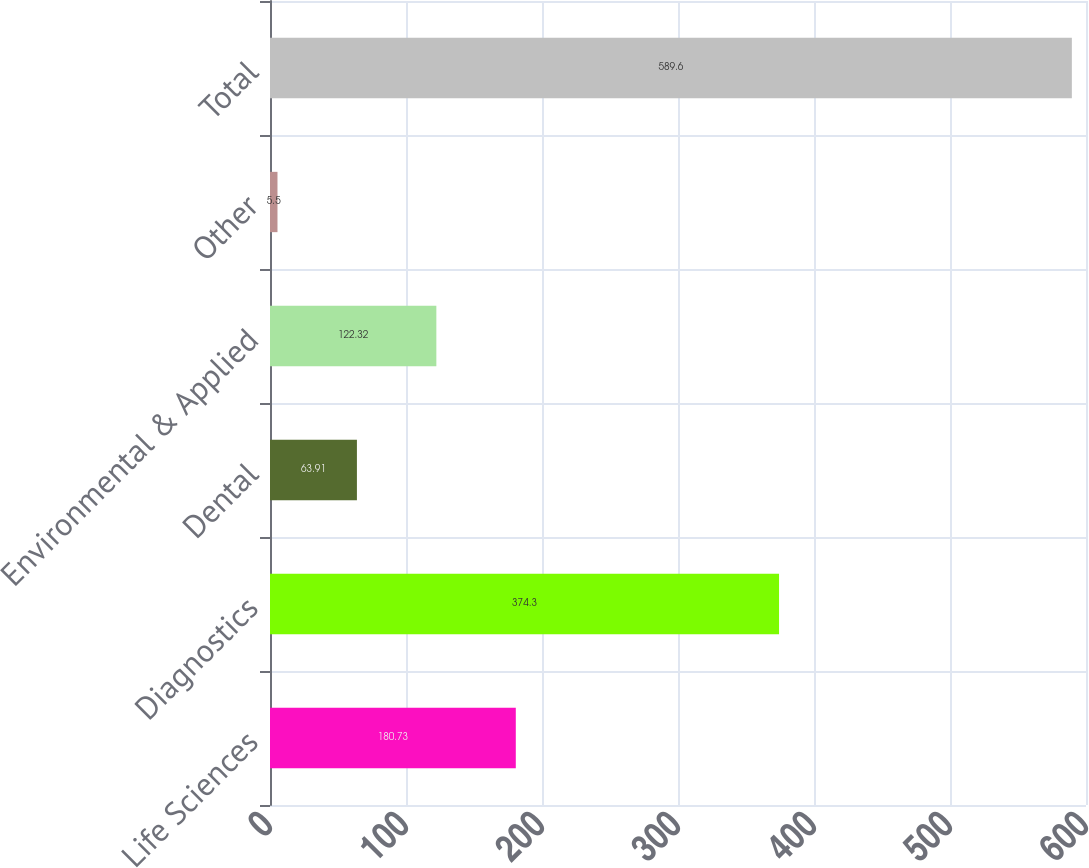<chart> <loc_0><loc_0><loc_500><loc_500><bar_chart><fcel>Life Sciences<fcel>Diagnostics<fcel>Dental<fcel>Environmental & Applied<fcel>Other<fcel>Total<nl><fcel>180.73<fcel>374.3<fcel>63.91<fcel>122.32<fcel>5.5<fcel>589.6<nl></chart> 